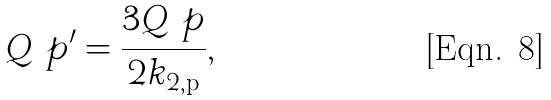<formula> <loc_0><loc_0><loc_500><loc_500>Q \ p ^ { \prime } = \frac { 3 Q \ p } { 2 k _ { 2 , \text {p} } } ,</formula> 